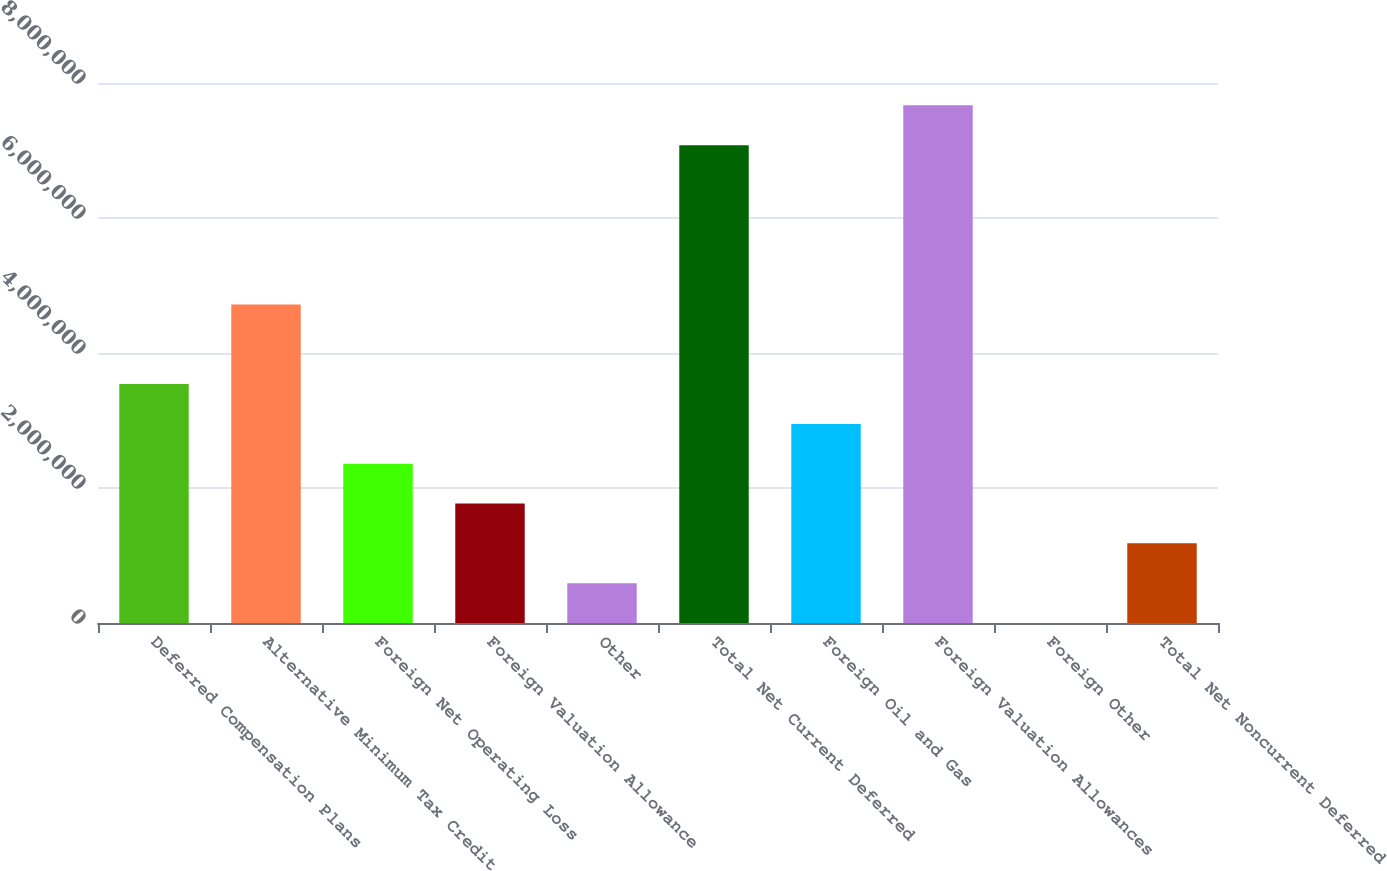Convert chart. <chart><loc_0><loc_0><loc_500><loc_500><bar_chart><fcel>Deferred Compensation Plans<fcel>Alternative Minimum Tax Credit<fcel>Foreign Net Operating Loss<fcel>Foreign Valuation Allowance<fcel>Other<fcel>Total Net Current Deferred<fcel>Foreign Oil and Gas<fcel>Foreign Valuation Allowances<fcel>Foreign Other<fcel>Total Net Noncurrent Deferred<nl><fcel>3.5399e+06<fcel>4.71971e+06<fcel>2.36008e+06<fcel>1.77017e+06<fcel>590348<fcel>7.07935e+06<fcel>2.94999e+06<fcel>7.66926e+06<fcel>438<fcel>1.18026e+06<nl></chart> 